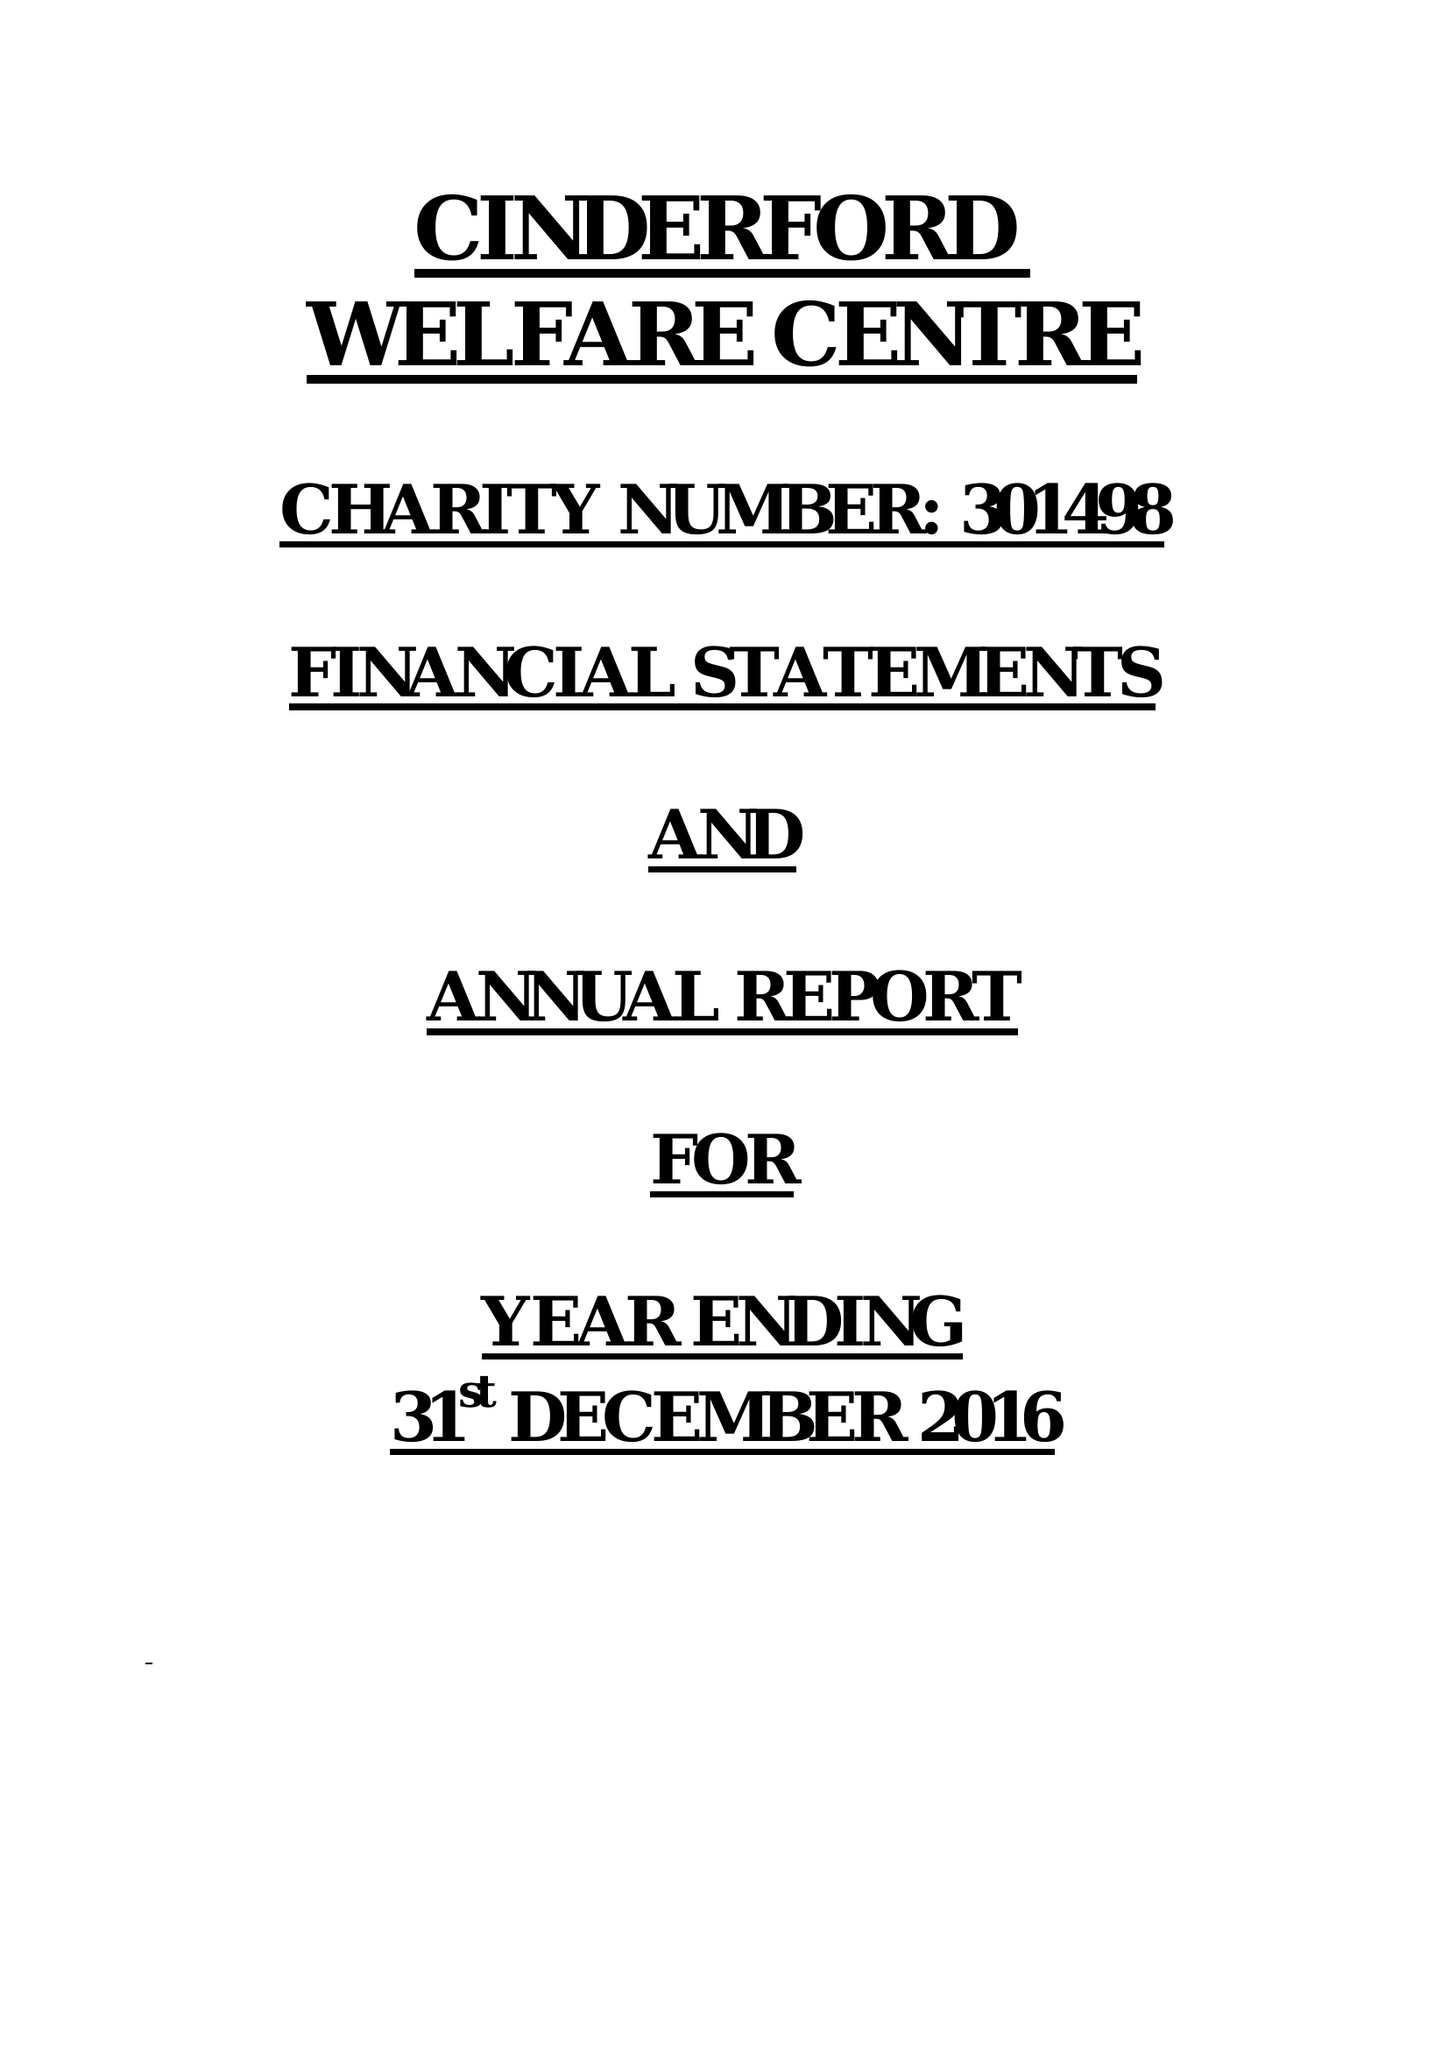What is the value for the charity_name?
Answer the question using a single word or phrase. Cinderford Welfare Centre 